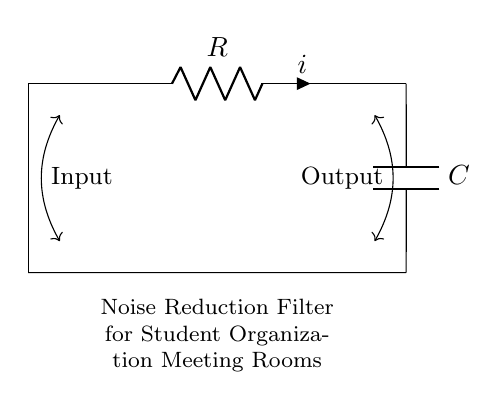What are the main components shown in the circuit? The circuit diagram shows a resistor and a capacitor as the main components.
Answer: Resistor and Capacitor What is the purpose of the circuit? The purpose, indicated in the diagram, is to function as a noise reduction filter for sound systems in meeting rooms.
Answer: Noise reduction filter In which orientation is the capacitor connected? The capacitor is connected vertically, with one terminal at the top and the other at the bottom.
Answer: Vertical What is the symbol for the resistor? The resistor is represented by a zigzag line in the circuit diagram.
Answer: Zigzag line If the resistance is twelve ohms and the capacitance is six microfarads, what is the time constant? The time constant, which is the product of resistance and capacitance, is calculated using the formula tau equals R times C. Here, twelve ohms times six microfarads equals seventy-two milliseconds.
Answer: Seventy-two milliseconds How does the output relate to the input in this circuit setup? The output is a filtered version of the input, meaning it reduces the noise and maintains the desired signal through the resistor-capacitor arrangement.
Answer: Filtered signal 